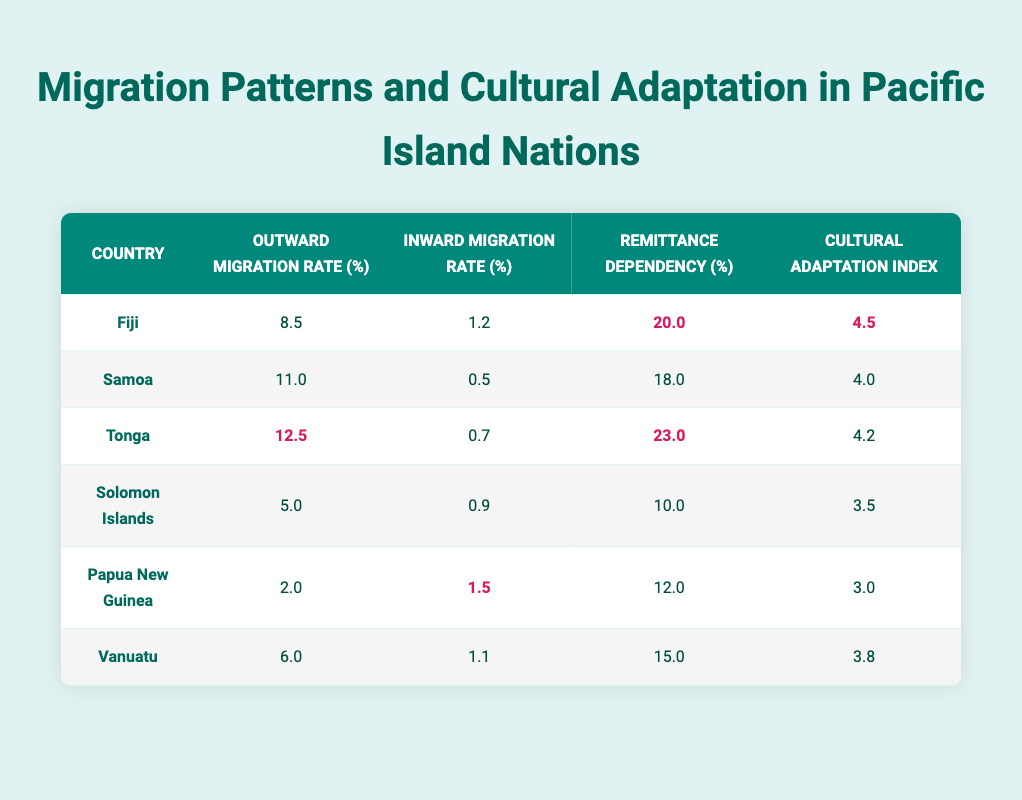What is the outward migration rate for Tonga? The table shows that Tonga has an outward migration rate of 12.5%.
Answer: 12.5% Which country has the highest cultural adaptation index? According to the table, Fiji has the highest cultural adaptation index listed at 4.5.
Answer: Fiji Is the inward migration rate for Samoa greater than for Solomon Islands? The table indicates that Samoa's inward migration rate is 0.5%, whereas Solomon Islands has an inward migration rate of 0.9%. Therefore, 0.5% is not greater than 0.9%.
Answer: No What is the average remittance dependency among the countries listed? To find the average, sum the remittance dependencies: 20.0 + 18.0 + 23.0 + 10.0 + 12.0 + 15.0 = 108. Then, divide by the number of countries (6): 108 / 6 = 18.
Answer: 18.0 Which country has the lowest outward migration rate, and what is that rate? From the table, the lowest outward migration rate is found for Papua New Guinea at 2.0%.
Answer: Papua New Guinea; 2.0% Are there any countries with a remittance dependency of less than 15%? The table shows that the remittance dependency for Solomon Islands (10.0%) and Papua New Guinea (12.0%) are both less than 15%.
Answer: Yes What is the difference between the cultural adaptation index of Fiji and Vanuatu? Fiji's cultural adaptation index is 4.5, while Vanuatu's is 3.8. The difference is calculated as 4.5 - 3.8 = 0.7.
Answer: 0.7 Which countries have an inward migration rate of above 1.0%? The table indicates that Fiji (1.2%), Papua New Guinea (1.5%), and Vanuatu (1.1%) have inward migration rates above 1.0%.
Answer: Fiji, Papua New Guinea, Vanuatu How do the outward migration rates for Samoa and Tonga compare? Samoa's outward migration rate is 11.0%, while Tonga's is 12.5%. Therefore, Tonga has a higher outward migration rate than Samoa.
Answer: Tonga has a higher rate 